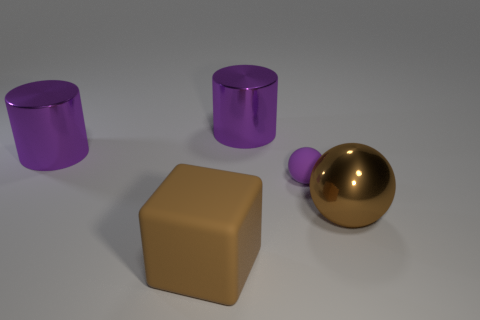There is a large brown object that is the same shape as the small purple object; what material is it?
Provide a short and direct response. Metal. There is a thing that is in front of the rubber sphere and left of the purple matte ball; what size is it?
Offer a terse response. Large. The large brown matte object has what shape?
Your answer should be compact. Cube. Are there any big purple cylinders in front of the purple object that is left of the big rubber object?
Ensure brevity in your answer.  No. What is the material of the brown ball that is the same size as the cube?
Your response must be concise. Metal. Are there any balls that have the same size as the brown block?
Your response must be concise. Yes. What is the large thing that is in front of the large sphere made of?
Provide a short and direct response. Rubber. Is the material of the purple cylinder right of the big brown matte cube the same as the large brown sphere?
Give a very brief answer. Yes. What is the shape of the brown thing that is the same size as the brown ball?
Offer a very short reply. Cube. How many other matte blocks are the same color as the rubber cube?
Make the answer very short. 0. 